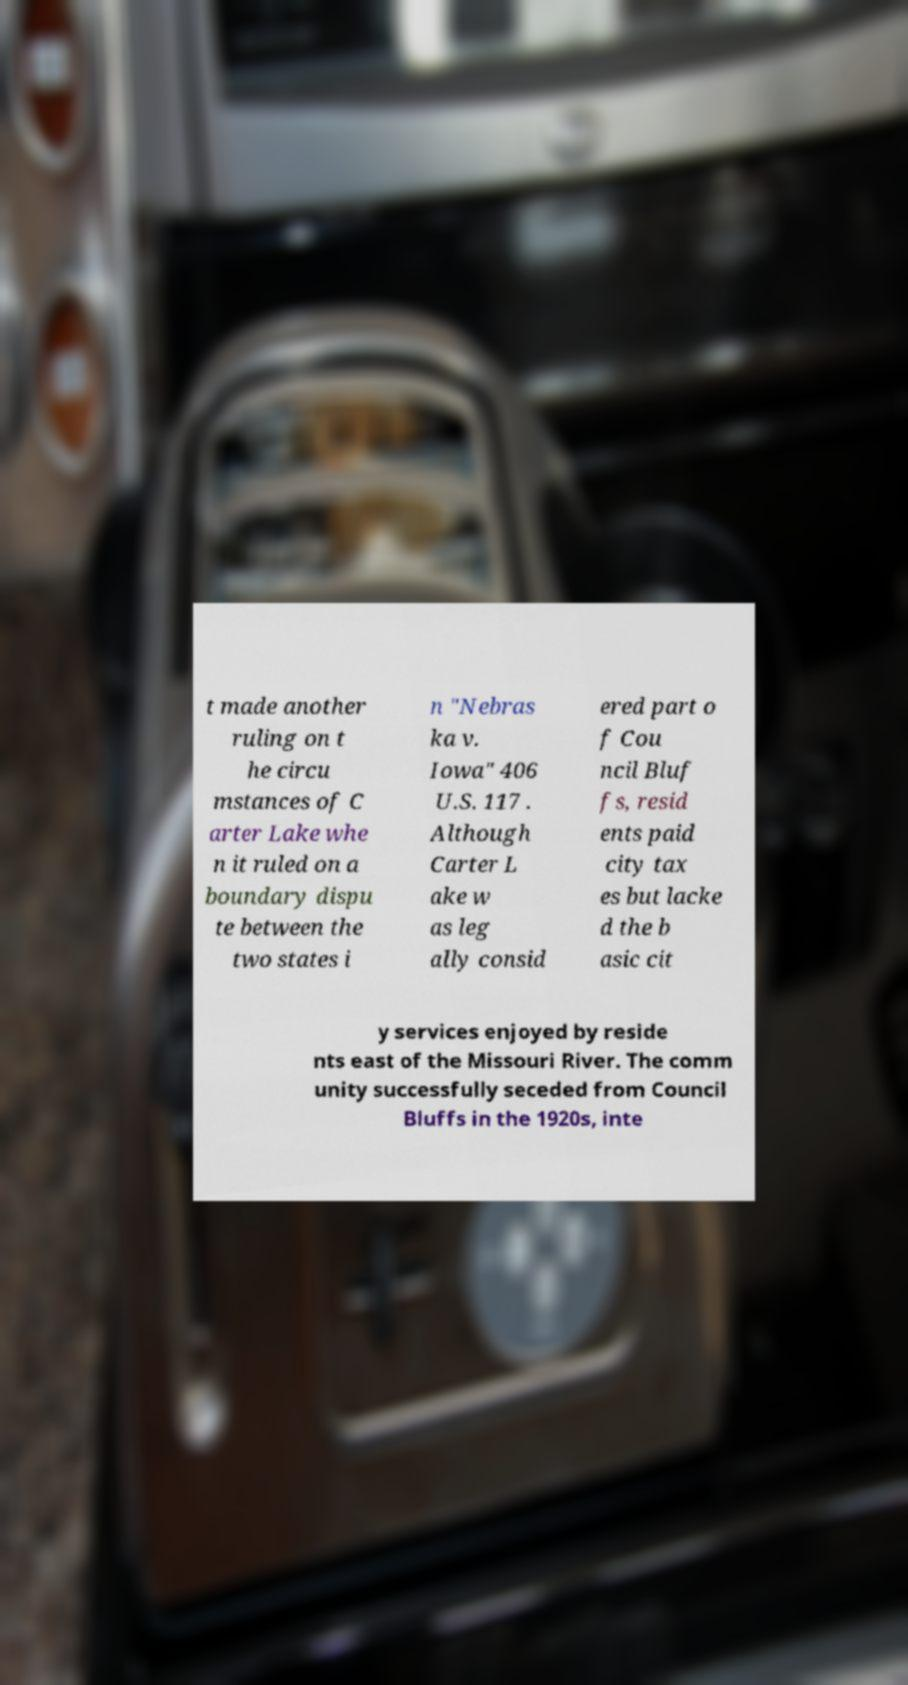What messages or text are displayed in this image? I need them in a readable, typed format. t made another ruling on t he circu mstances of C arter Lake whe n it ruled on a boundary dispu te between the two states i n "Nebras ka v. Iowa" 406 U.S. 117 . Although Carter L ake w as leg ally consid ered part o f Cou ncil Bluf fs, resid ents paid city tax es but lacke d the b asic cit y services enjoyed by reside nts east of the Missouri River. The comm unity successfully seceded from Council Bluffs in the 1920s, inte 